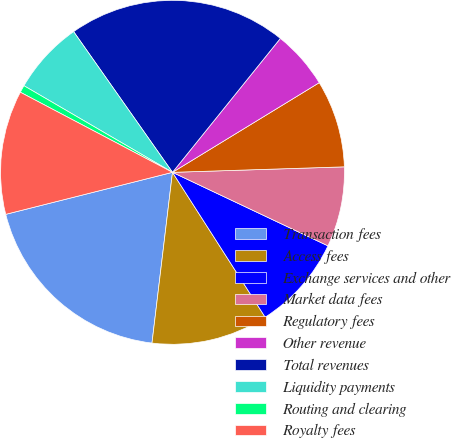Convert chart to OTSL. <chart><loc_0><loc_0><loc_500><loc_500><pie_chart><fcel>Transaction fees<fcel>Access fees<fcel>Exchange services and other<fcel>Market data fees<fcel>Regulatory fees<fcel>Other revenue<fcel>Total revenues<fcel>Liquidity payments<fcel>Routing and clearing<fcel>Royalty fees<nl><fcel>19.17%<fcel>10.96%<fcel>8.91%<fcel>7.54%<fcel>8.22%<fcel>5.48%<fcel>20.54%<fcel>6.85%<fcel>0.69%<fcel>11.64%<nl></chart> 